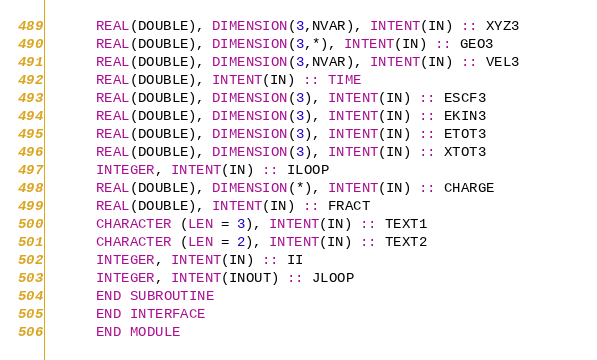<code> <loc_0><loc_0><loc_500><loc_500><_FORTRAN_>      REAL(DOUBLE), DIMENSION(3,NVAR), INTENT(IN) :: XYZ3 
      REAL(DOUBLE), DIMENSION(3,*), INTENT(IN) :: GEO3 
      REAL(DOUBLE), DIMENSION(3,NVAR), INTENT(IN) :: VEL3       
      REAL(DOUBLE), INTENT(IN) :: TIME 
      REAL(DOUBLE), DIMENSION(3), INTENT(IN) :: ESCF3 
      REAL(DOUBLE), DIMENSION(3), INTENT(IN) :: EKIN3 
      REAL(DOUBLE), DIMENSION(3), INTENT(IN) :: ETOT3 
      REAL(DOUBLE), DIMENSION(3), INTENT(IN) :: XTOT3 
      INTEGER, INTENT(IN) :: ILOOP 
      REAL(DOUBLE), DIMENSION(*), INTENT(IN) :: CHARGE 
      REAL(DOUBLE), INTENT(IN) :: FRACT 
      CHARACTER (LEN = 3), INTENT(IN) :: TEXT1 
      CHARACTER (LEN = 2), INTENT(IN) :: TEXT2 
      INTEGER, INTENT(IN) :: II 
      INTEGER, INTENT(INOUT) :: JLOOP 
      END SUBROUTINE  
      END INTERFACE 
      END MODULE 
</code> 